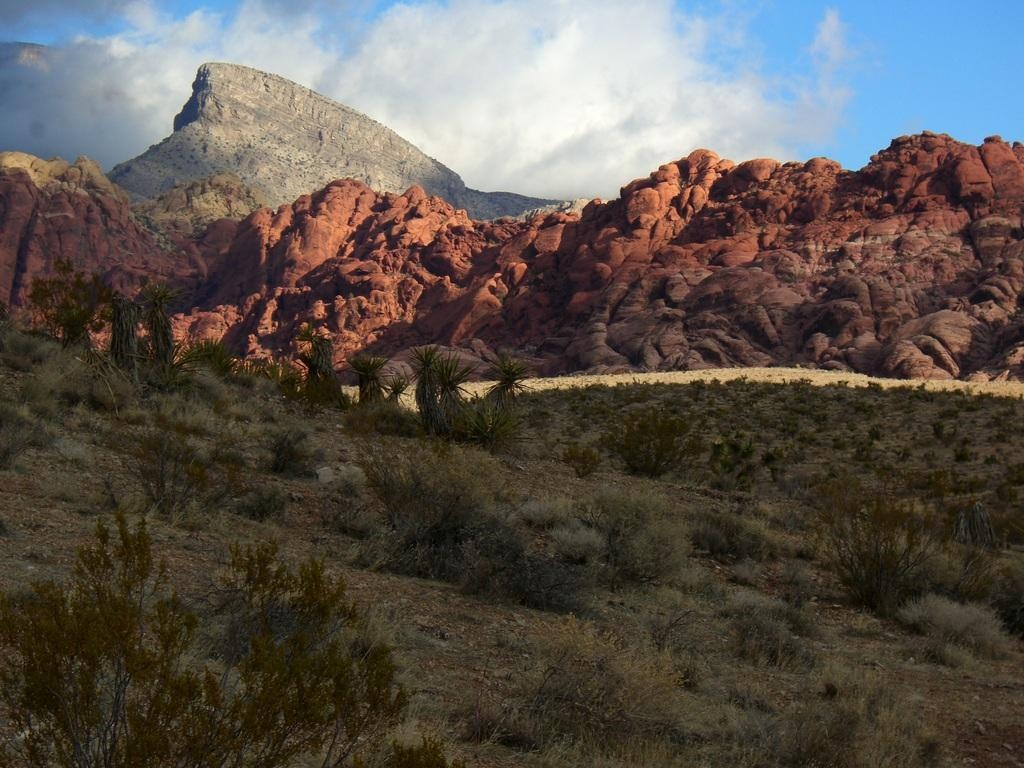What can be seen on the ground in the image? The ground is visible in the image, and there is grass and plants on the ground. What is the terrain like in the image? The terrain features grass, plants, and mountains in the background. What is visible in the sky in the image? The sky is visible in the image, and it is blue and white in color. What type of substance is being used by the chickens to reason in the image? There are no chickens present in the image, and therefore no reasoning or substance can be observed. 